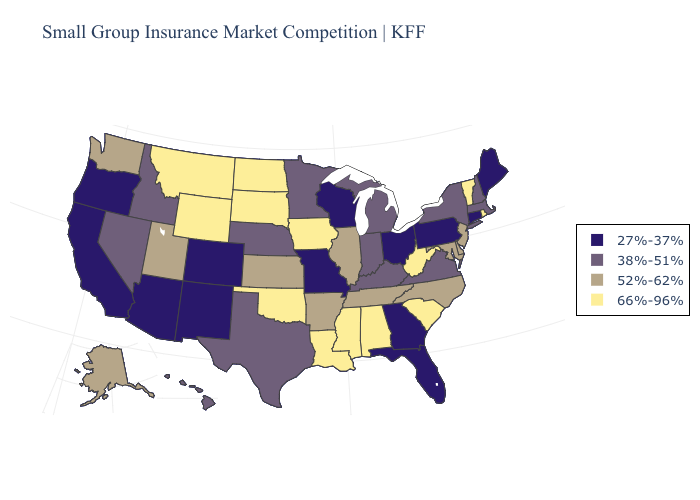What is the value of North Carolina?
Answer briefly. 52%-62%. Name the states that have a value in the range 52%-62%?
Write a very short answer. Alaska, Arkansas, Delaware, Illinois, Kansas, Maryland, New Jersey, North Carolina, Tennessee, Utah, Washington. Name the states that have a value in the range 52%-62%?
Give a very brief answer. Alaska, Arkansas, Delaware, Illinois, Kansas, Maryland, New Jersey, North Carolina, Tennessee, Utah, Washington. Among the states that border New Mexico , does Texas have the lowest value?
Short answer required. No. What is the value of Ohio?
Keep it brief. 27%-37%. Name the states that have a value in the range 27%-37%?
Keep it brief. Arizona, California, Colorado, Connecticut, Florida, Georgia, Maine, Missouri, New Mexico, Ohio, Oregon, Pennsylvania, Wisconsin. How many symbols are there in the legend?
Answer briefly. 4. Which states have the lowest value in the Northeast?
Short answer required. Connecticut, Maine, Pennsylvania. What is the highest value in states that border Maryland?
Short answer required. 66%-96%. Among the states that border Nevada , does Utah have the highest value?
Short answer required. Yes. Does Iowa have the highest value in the MidWest?
Answer briefly. Yes. Does North Dakota have the highest value in the USA?
Quick response, please. Yes. What is the value of Maryland?
Give a very brief answer. 52%-62%. What is the lowest value in the Northeast?
Give a very brief answer. 27%-37%. What is the value of Missouri?
Keep it brief. 27%-37%. 